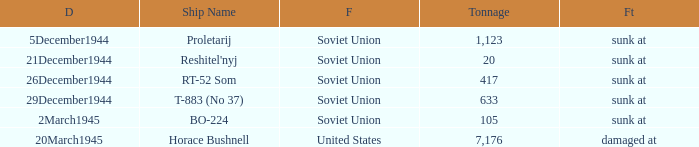How did the ship named proletarij finish its service? Sunk at. 